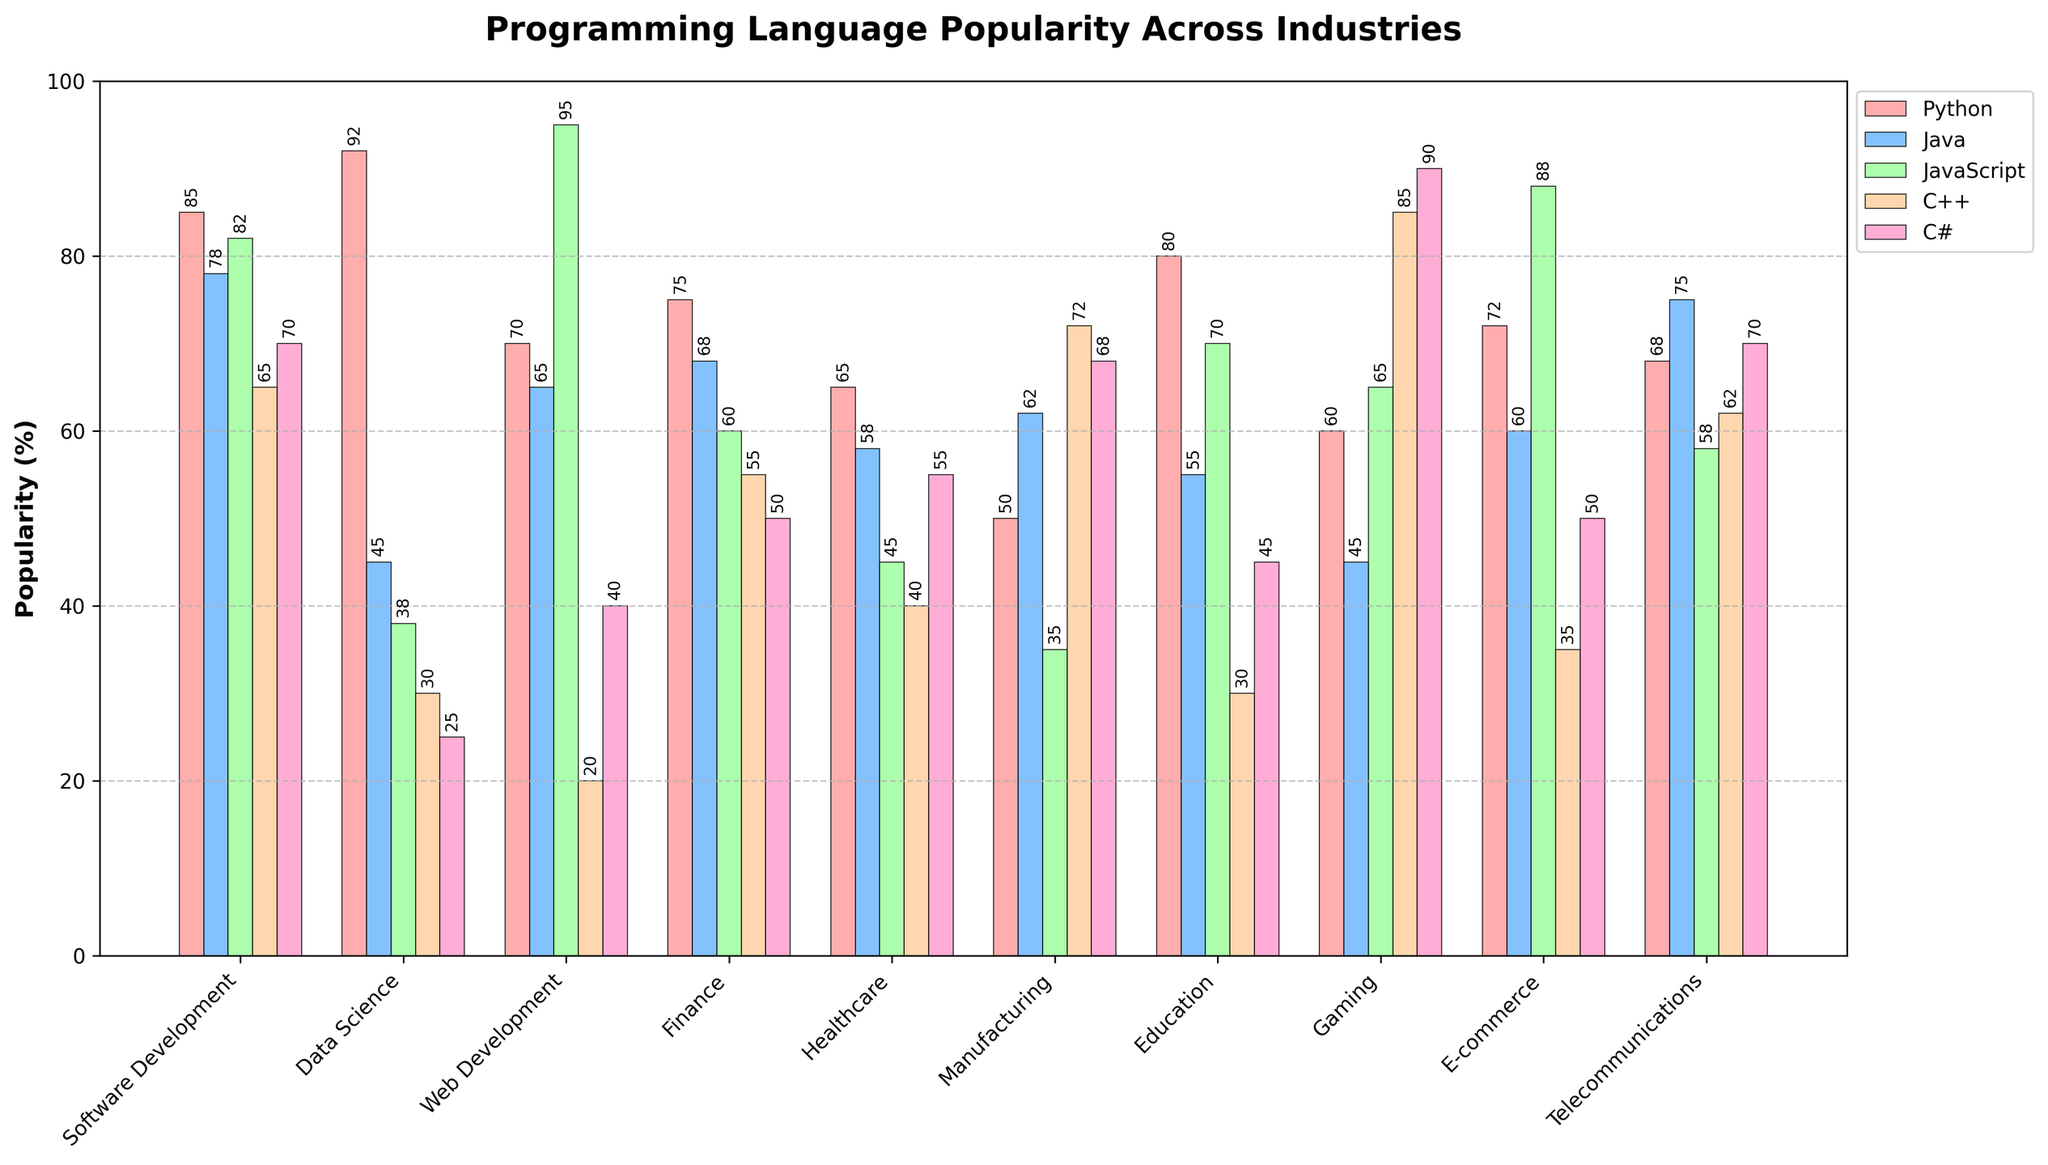Which industry has the highest popularity for Python? By looking at the height of the bars representing Python across different industries, the tallest bar (highest popularity) is found in Data Science.
Answer: Data Science What is the average popularity of JavaScript across all industries? Sum the popularity values of JavaScript for each industry and divide by the number of industries: (82 + 38 + 95 + 60 + 45 + 35 + 70 + 65 + 88 + 58) / 10 = 636 / 10 = 63.6
Answer: 63.6 Which programming language is the least popular in the Manufacturing industry? In the Manufacturing industry, compare the heights of all bars representing different programming languages. The shortest bar is for JavaScript with a popularity of 35.
Answer: JavaScript Which language has the most consistent popularity (least variation) across these industries? To determine the consistency, look at the heights of the bars for each language across all industries. Java seems to have the least variation in the height of its bars across industries.
Answer: Java In the Healthcare industry, what is the combined popularity of Python and C#? Add the popularity values of Python and C# in Healthcare: 65 + 55 = 120
Answer: 120 Compare the popularity of C++ in Gaming and Web Development. Which industry has a higher popularity? By comparing the height of the bars representing C++ in Gaming and Web Development, C++ is more popular in Gaming (85) than in Web Development (20).
Answer: Gaming Which industry has higher popularity for JavaScript compared to C#? Compare the heights of the bars for JavaScript and C# in each industry: JavaScript has higher popularity than C# in Software Development, Data Science, Web Development, Finance, Education, Gaming, and E-commerce.
Answer: Several industries (Software Development, Data Science, Web Development, Finance, Education, Gaming, E-commerce) In the E-commerce industry, which programming language is the second most popular? In E-commerce, compare the heights of all the bars. The first most popular is JavaScript (88), and the second most popular is Python (72).
Answer: Python 